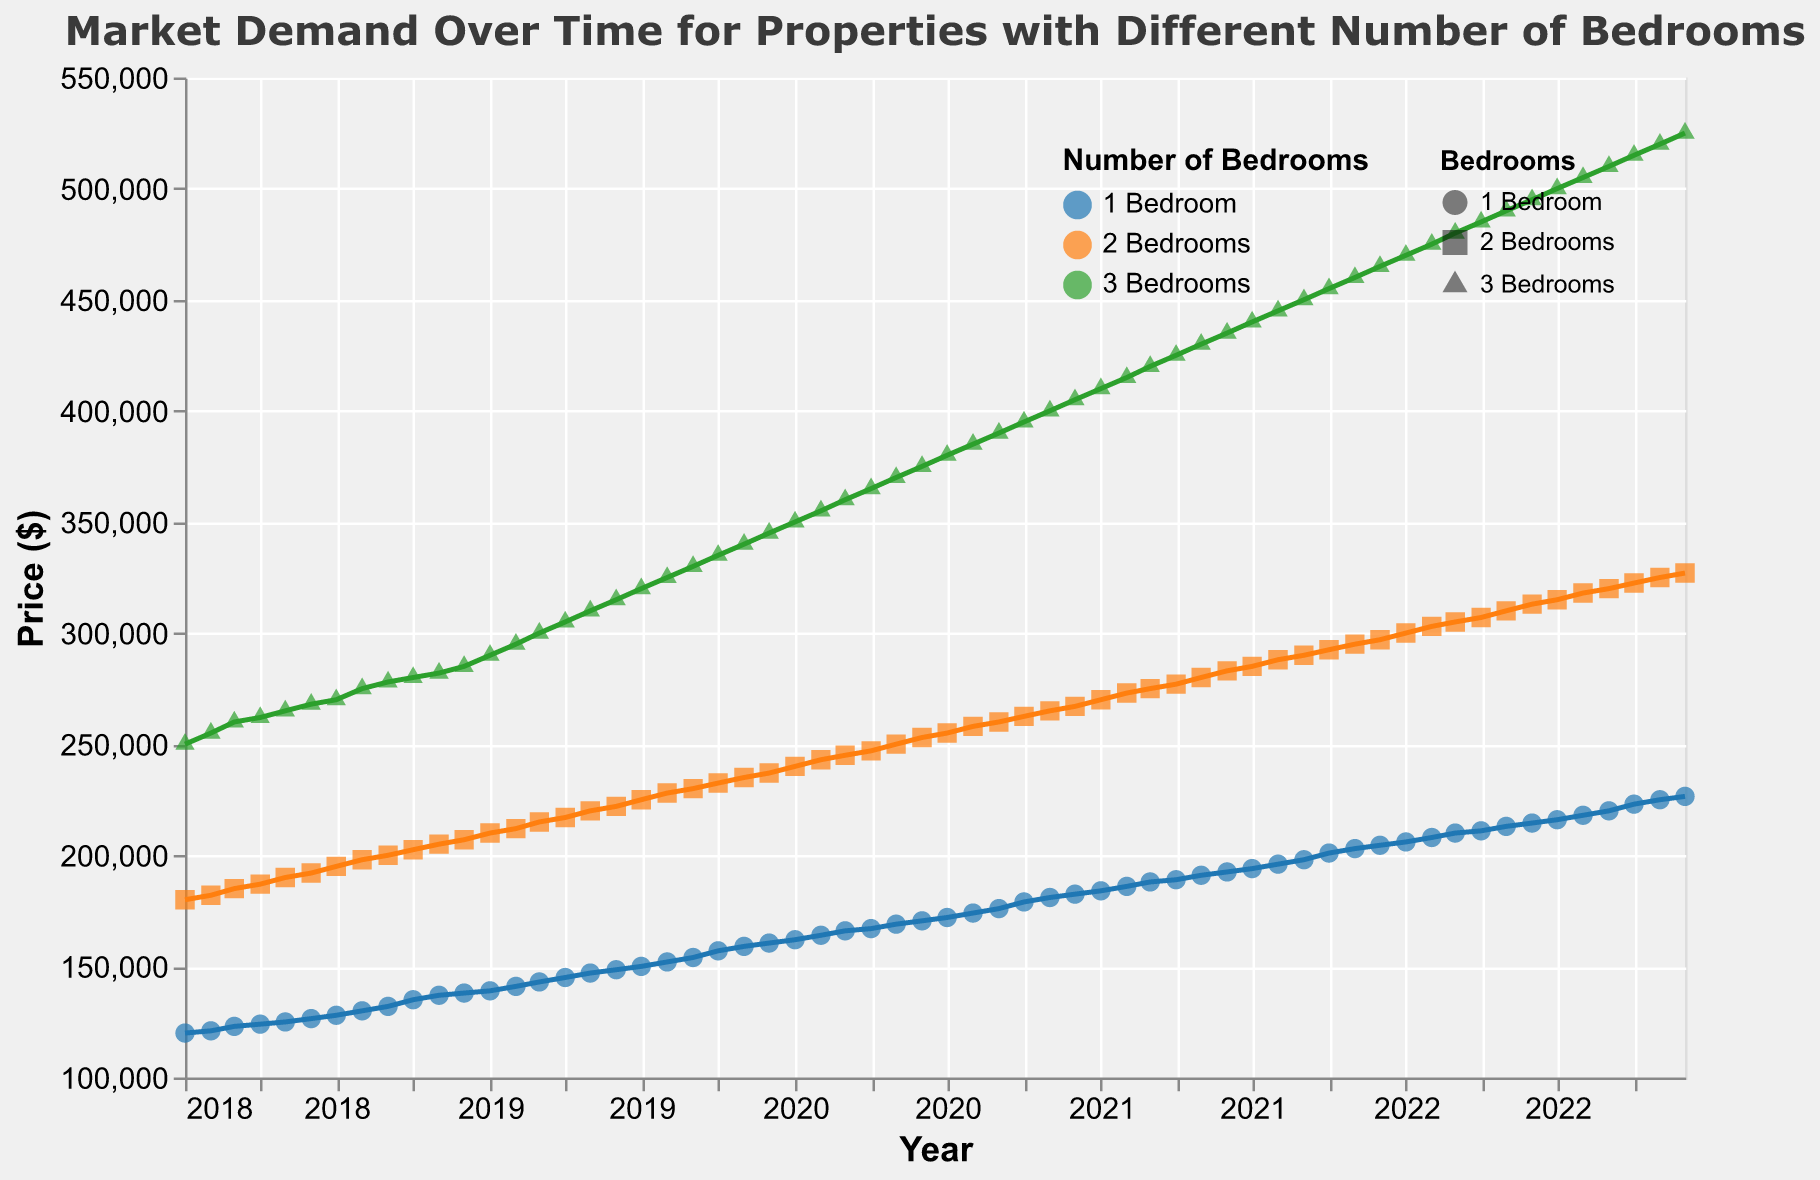What is the overall trend for the prices of 3-bedroom properties over time? The scatter plot with the trend line shows an upward trend for 3-bedroom property prices from January 2018 to December 2022. This can be identified by the consistently increasing line representing 3-bedroom properties.
Answer: Upward trend How much was the price of a 2-bedroom property in January 2019? By looking at the data point for January 2019, we see that the price for a 2-bedroom property was $210,000.
Answer: $210,000 What is the difference in the price of 1-bedroom properties between January 2018 and December 2022? In January 2018, the price of a 1-bedroom property was $120,000, and in December 2022, it was $226,500. The difference is calculated as $226,500 - $120,000.
Answer: $106,500 Which type of property saw the highest price increase over the given period? By comparing the initial and final prices for each property type from January 2018 to December 2022, we can deduce that 3-bedroom properties saw the highest increase from $250,000 to $525,000, which is a difference of $275,000.
Answer: 3-bedroom properties During which year did 2-bedroom properties see the most significant price increase? To find the most significant yearly increase, we can examine the trend lines and notice that the steepest increase for 2-bedroom properties was between 2020 and 2021, where the price went from $255,000 to $285,000.
Answer: 2020-2021 How does the price of a 1-bedroom property in December 2018 compare to a 3-bedroom property in the same month? The price of a 1-bedroom property in December 2018 was $138,000, while the price of a 3-bedroom property was $285,000. The 3-bedroom property is significantly more expensive by $147,000.
Answer: 3-bedroom is more expensive by $147,000 What are the colors used to represent the different property types? The color for 3-bedroom properties is blue, the color for 2-bedroom properties is orange, and the color for 1-bedroom properties is green.
Answer: Blue for 3 bedrooms, orange for 2 bedrooms, green for 1 bedroom Are there any noticeable changes in the price trend during the COVID-19 pandemic in 2020? By examining the trend lines for each property type, a noticeable change can be observed around early 2020. The prices for all property types show a marked increase from around March 2020 and continue to rise steeply.
Answer: Yes What was the price of a 3-bedroom property in June 2021? Referring to the trend line at the data point for June 2021 for a 3-bedroom property, the price was $435,000.
Answer: $435,000 